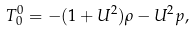<formula> <loc_0><loc_0><loc_500><loc_500>T ^ { 0 } _ { 0 } = - ( 1 + U ^ { 2 } ) \rho - U ^ { 2 } p ,</formula> 